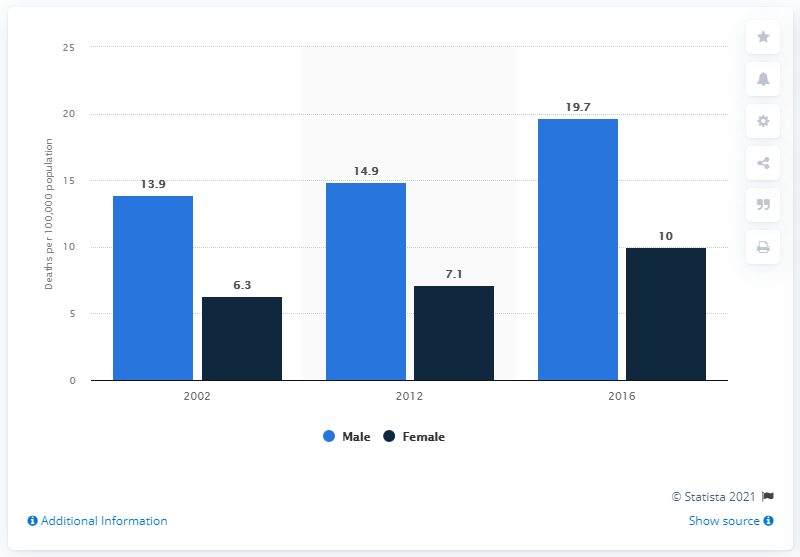Outline some significant characteristics in this image. The male death rate per 100,000 people was 19.7 during a specific time period. 